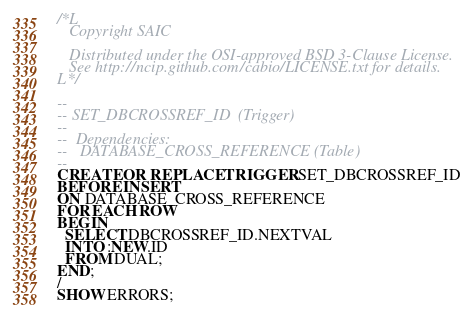<code> <loc_0><loc_0><loc_500><loc_500><_SQL_>/*L
   Copyright SAIC

   Distributed under the OSI-approved BSD 3-Clause License.
   See http://ncip.github.com/cabio/LICENSE.txt for details.
L*/

--
-- SET_DBCROSSREF_ID  (Trigger) 
--
--  Dependencies: 
--   DATABASE_CROSS_REFERENCE (Table)
--
CREATE OR REPLACE TRIGGER SET_DBCROSSREF_ID
BEFORE INSERT
ON DATABASE_CROSS_REFERENCE
FOR EACH ROW
BEGIN
  SELECT DBCROSSREF_ID.NEXTVAL
  INTO :NEW.ID
  FROM DUAL;
END;
/
SHOW ERRORS;



</code> 